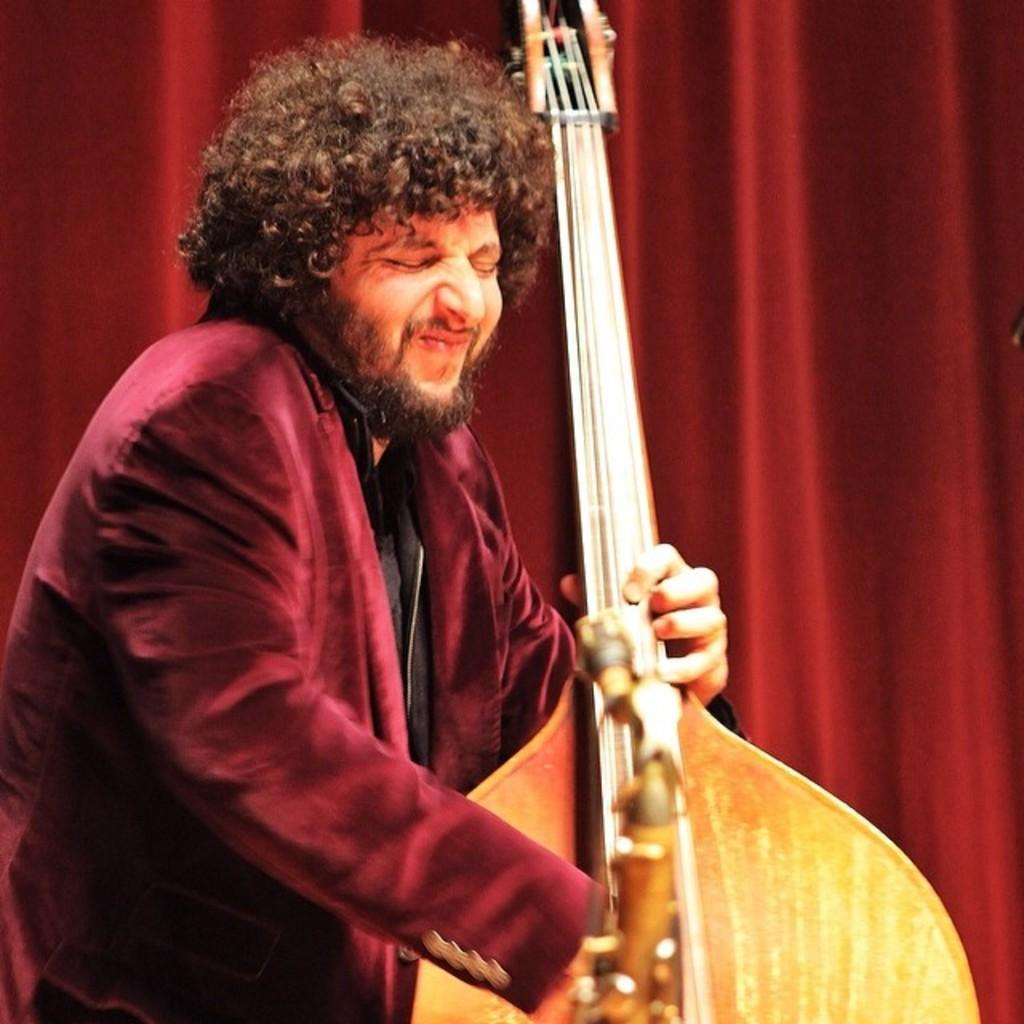What is the man in the image doing? The man is playing a guitar in the image. What is the man wearing in the image? The man is wearing a red jacket and shirt in the image. What color is the cloth visible in the background of the image? The cloth visible in the background of the image is red. What is the opinion of the wave in the image? There is no wave present in the image, so it is not possible to determine its opinion. 